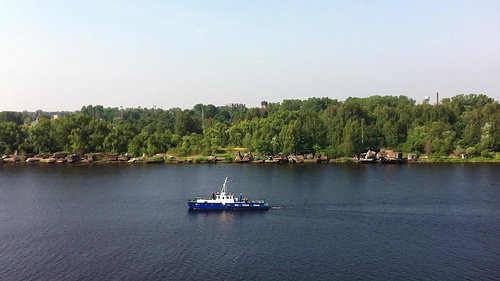Please provide a short description for this region: [0.34, 0.54, 0.56, 0.66]. This region features a strikingly colored blue and white ship, possibly indicating a vessel used for leisure or light commercial activities on the river. 